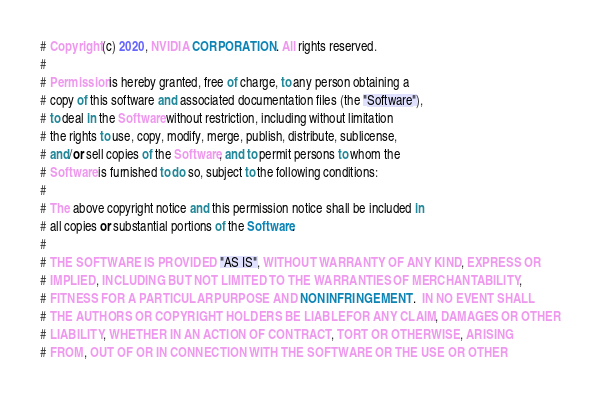Convert code to text. <code><loc_0><loc_0><loc_500><loc_500><_OCaml_># Copyright (c) 2020, NVIDIA CORPORATION. All rights reserved.
#
# Permission is hereby granted, free of charge, to any person obtaining a
# copy of this software and associated documentation files (the "Software"),
# to deal in the Software without restriction, including without limitation
# the rights to use, copy, modify, merge, publish, distribute, sublicense,
# and/or sell copies of the Software, and to permit persons to whom the
# Software is furnished to do so, subject to the following conditions:
#
# The above copyright notice and this permission notice shall be included in
# all copies or substantial portions of the Software.
#
# THE SOFTWARE IS PROVIDED "AS IS", WITHOUT WARRANTY OF ANY KIND, EXPRESS OR
# IMPLIED, INCLUDING BUT NOT LIMITED TO THE WARRANTIES OF MERCHANTABILITY,
# FITNESS FOR A PARTICULAR PURPOSE AND NONINFRINGEMENT.  IN NO EVENT SHALL
# THE AUTHORS OR COPYRIGHT HOLDERS BE LIABLE FOR ANY CLAIM, DAMAGES OR OTHER
# LIABILITY, WHETHER IN AN ACTION OF CONTRACT, TORT OR OTHERWISE, ARISING
# FROM, OUT OF OR IN CONNECTION WITH THE SOFTWARE OR THE USE OR OTHER</code> 